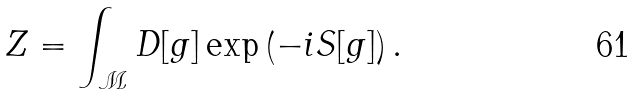Convert formula to latex. <formula><loc_0><loc_0><loc_500><loc_500>Z = \int _ { \mathcal { M } } D [ g ] \exp \left ( - i S [ g ] \right ) .</formula> 